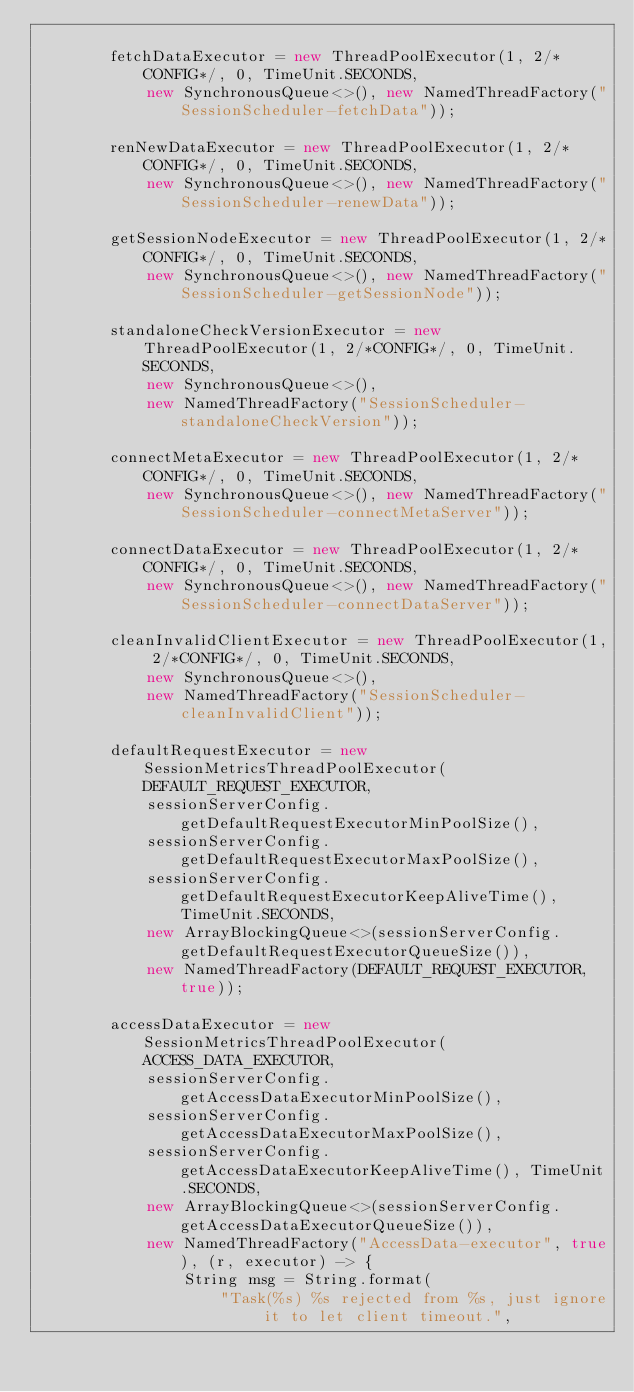Convert code to text. <code><loc_0><loc_0><loc_500><loc_500><_Java_>
        fetchDataExecutor = new ThreadPoolExecutor(1, 2/*CONFIG*/, 0, TimeUnit.SECONDS,
            new SynchronousQueue<>(), new NamedThreadFactory("SessionScheduler-fetchData"));

        renNewDataExecutor = new ThreadPoolExecutor(1, 2/*CONFIG*/, 0, TimeUnit.SECONDS,
            new SynchronousQueue<>(), new NamedThreadFactory("SessionScheduler-renewData"));

        getSessionNodeExecutor = new ThreadPoolExecutor(1, 2/*CONFIG*/, 0, TimeUnit.SECONDS,
            new SynchronousQueue<>(), new NamedThreadFactory("SessionScheduler-getSessionNode"));

        standaloneCheckVersionExecutor = new ThreadPoolExecutor(1, 2/*CONFIG*/, 0, TimeUnit.SECONDS,
            new SynchronousQueue<>(),
            new NamedThreadFactory("SessionScheduler-standaloneCheckVersion"));

        connectMetaExecutor = new ThreadPoolExecutor(1, 2/*CONFIG*/, 0, TimeUnit.SECONDS,
            new SynchronousQueue<>(), new NamedThreadFactory("SessionScheduler-connectMetaServer"));

        connectDataExecutor = new ThreadPoolExecutor(1, 2/*CONFIG*/, 0, TimeUnit.SECONDS,
            new SynchronousQueue<>(), new NamedThreadFactory("SessionScheduler-connectDataServer"));

        cleanInvalidClientExecutor = new ThreadPoolExecutor(1, 2/*CONFIG*/, 0, TimeUnit.SECONDS,
            new SynchronousQueue<>(),
            new NamedThreadFactory("SessionScheduler-cleanInvalidClient"));

        defaultRequestExecutor = new SessionMetricsThreadPoolExecutor(DEFAULT_REQUEST_EXECUTOR,
            sessionServerConfig.getDefaultRequestExecutorMinPoolSize(),
            sessionServerConfig.getDefaultRequestExecutorMaxPoolSize(),
            sessionServerConfig.getDefaultRequestExecutorKeepAliveTime(), TimeUnit.SECONDS,
            new ArrayBlockingQueue<>(sessionServerConfig.getDefaultRequestExecutorQueueSize()),
            new NamedThreadFactory(DEFAULT_REQUEST_EXECUTOR, true));

        accessDataExecutor = new SessionMetricsThreadPoolExecutor(ACCESS_DATA_EXECUTOR,
            sessionServerConfig.getAccessDataExecutorMinPoolSize(),
            sessionServerConfig.getAccessDataExecutorMaxPoolSize(),
            sessionServerConfig.getAccessDataExecutorKeepAliveTime(), TimeUnit.SECONDS,
            new ArrayBlockingQueue<>(sessionServerConfig.getAccessDataExecutorQueueSize()),
            new NamedThreadFactory("AccessData-executor", true), (r, executor) -> {
                String msg = String.format(
                    "Task(%s) %s rejected from %s, just ignore it to let client timeout.",</code> 